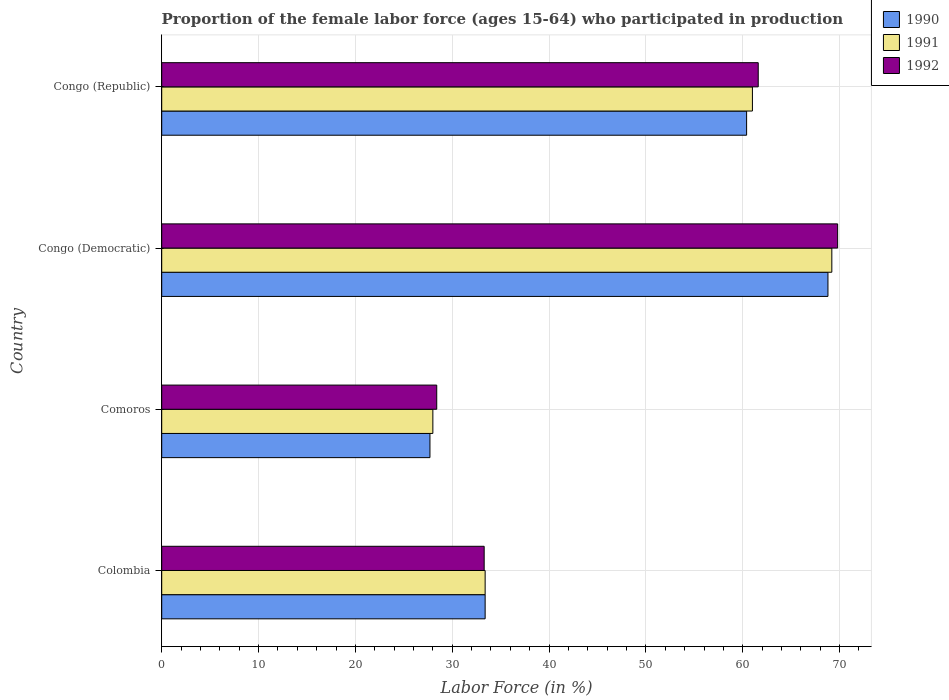How many groups of bars are there?
Your answer should be very brief. 4. Are the number of bars on each tick of the Y-axis equal?
Keep it short and to the point. Yes. How many bars are there on the 3rd tick from the top?
Provide a succinct answer. 3. What is the label of the 3rd group of bars from the top?
Keep it short and to the point. Comoros. In how many cases, is the number of bars for a given country not equal to the number of legend labels?
Your answer should be very brief. 0. What is the proportion of the female labor force who participated in production in 1991 in Congo (Republic)?
Provide a succinct answer. 61. Across all countries, what is the maximum proportion of the female labor force who participated in production in 1992?
Offer a very short reply. 69.8. Across all countries, what is the minimum proportion of the female labor force who participated in production in 1990?
Make the answer very short. 27.7. In which country was the proportion of the female labor force who participated in production in 1991 maximum?
Offer a very short reply. Congo (Democratic). In which country was the proportion of the female labor force who participated in production in 1990 minimum?
Make the answer very short. Comoros. What is the total proportion of the female labor force who participated in production in 1991 in the graph?
Offer a terse response. 191.6. What is the difference between the proportion of the female labor force who participated in production in 1992 in Congo (Democratic) and that in Congo (Republic)?
Provide a short and direct response. 8.2. What is the difference between the proportion of the female labor force who participated in production in 1992 in Comoros and the proportion of the female labor force who participated in production in 1990 in Congo (Republic)?
Offer a terse response. -32. What is the average proportion of the female labor force who participated in production in 1990 per country?
Keep it short and to the point. 47.58. What is the difference between the proportion of the female labor force who participated in production in 1990 and proportion of the female labor force who participated in production in 1992 in Comoros?
Your response must be concise. -0.7. In how many countries, is the proportion of the female labor force who participated in production in 1992 greater than 24 %?
Offer a very short reply. 4. What is the ratio of the proportion of the female labor force who participated in production in 1992 in Comoros to that in Congo (Democratic)?
Make the answer very short. 0.41. Is the difference between the proportion of the female labor force who participated in production in 1990 in Comoros and Congo (Democratic) greater than the difference between the proportion of the female labor force who participated in production in 1992 in Comoros and Congo (Democratic)?
Offer a very short reply. Yes. What is the difference between the highest and the second highest proportion of the female labor force who participated in production in 1992?
Give a very brief answer. 8.2. What is the difference between the highest and the lowest proportion of the female labor force who participated in production in 1990?
Provide a short and direct response. 41.1. In how many countries, is the proportion of the female labor force who participated in production in 1991 greater than the average proportion of the female labor force who participated in production in 1991 taken over all countries?
Your answer should be compact. 2. Is it the case that in every country, the sum of the proportion of the female labor force who participated in production in 1990 and proportion of the female labor force who participated in production in 1991 is greater than the proportion of the female labor force who participated in production in 1992?
Make the answer very short. Yes. How many bars are there?
Your answer should be compact. 12. How many countries are there in the graph?
Your answer should be compact. 4. Does the graph contain grids?
Offer a very short reply. Yes. Where does the legend appear in the graph?
Your answer should be very brief. Top right. What is the title of the graph?
Keep it short and to the point. Proportion of the female labor force (ages 15-64) who participated in production. Does "2006" appear as one of the legend labels in the graph?
Make the answer very short. No. What is the Labor Force (in %) in 1990 in Colombia?
Provide a succinct answer. 33.4. What is the Labor Force (in %) of 1991 in Colombia?
Your response must be concise. 33.4. What is the Labor Force (in %) in 1992 in Colombia?
Ensure brevity in your answer.  33.3. What is the Labor Force (in %) in 1990 in Comoros?
Offer a terse response. 27.7. What is the Labor Force (in %) of 1992 in Comoros?
Keep it short and to the point. 28.4. What is the Labor Force (in %) of 1990 in Congo (Democratic)?
Your answer should be compact. 68.8. What is the Labor Force (in %) in 1991 in Congo (Democratic)?
Keep it short and to the point. 69.2. What is the Labor Force (in %) of 1992 in Congo (Democratic)?
Give a very brief answer. 69.8. What is the Labor Force (in %) of 1990 in Congo (Republic)?
Offer a very short reply. 60.4. What is the Labor Force (in %) of 1992 in Congo (Republic)?
Provide a short and direct response. 61.6. Across all countries, what is the maximum Labor Force (in %) in 1990?
Provide a succinct answer. 68.8. Across all countries, what is the maximum Labor Force (in %) of 1991?
Ensure brevity in your answer.  69.2. Across all countries, what is the maximum Labor Force (in %) in 1992?
Provide a succinct answer. 69.8. Across all countries, what is the minimum Labor Force (in %) of 1990?
Provide a succinct answer. 27.7. Across all countries, what is the minimum Labor Force (in %) of 1991?
Provide a short and direct response. 28. Across all countries, what is the minimum Labor Force (in %) in 1992?
Provide a short and direct response. 28.4. What is the total Labor Force (in %) in 1990 in the graph?
Provide a succinct answer. 190.3. What is the total Labor Force (in %) of 1991 in the graph?
Your answer should be very brief. 191.6. What is the total Labor Force (in %) of 1992 in the graph?
Offer a very short reply. 193.1. What is the difference between the Labor Force (in %) of 1990 in Colombia and that in Comoros?
Give a very brief answer. 5.7. What is the difference between the Labor Force (in %) of 1992 in Colombia and that in Comoros?
Make the answer very short. 4.9. What is the difference between the Labor Force (in %) of 1990 in Colombia and that in Congo (Democratic)?
Make the answer very short. -35.4. What is the difference between the Labor Force (in %) of 1991 in Colombia and that in Congo (Democratic)?
Provide a short and direct response. -35.8. What is the difference between the Labor Force (in %) of 1992 in Colombia and that in Congo (Democratic)?
Your answer should be compact. -36.5. What is the difference between the Labor Force (in %) in 1990 in Colombia and that in Congo (Republic)?
Provide a succinct answer. -27. What is the difference between the Labor Force (in %) in 1991 in Colombia and that in Congo (Republic)?
Your response must be concise. -27.6. What is the difference between the Labor Force (in %) in 1992 in Colombia and that in Congo (Republic)?
Offer a terse response. -28.3. What is the difference between the Labor Force (in %) of 1990 in Comoros and that in Congo (Democratic)?
Provide a short and direct response. -41.1. What is the difference between the Labor Force (in %) of 1991 in Comoros and that in Congo (Democratic)?
Your response must be concise. -41.2. What is the difference between the Labor Force (in %) in 1992 in Comoros and that in Congo (Democratic)?
Your response must be concise. -41.4. What is the difference between the Labor Force (in %) of 1990 in Comoros and that in Congo (Republic)?
Offer a very short reply. -32.7. What is the difference between the Labor Force (in %) of 1991 in Comoros and that in Congo (Republic)?
Your answer should be compact. -33. What is the difference between the Labor Force (in %) in 1992 in Comoros and that in Congo (Republic)?
Your answer should be very brief. -33.2. What is the difference between the Labor Force (in %) in 1992 in Congo (Democratic) and that in Congo (Republic)?
Your answer should be compact. 8.2. What is the difference between the Labor Force (in %) of 1990 in Colombia and the Labor Force (in %) of 1991 in Congo (Democratic)?
Ensure brevity in your answer.  -35.8. What is the difference between the Labor Force (in %) of 1990 in Colombia and the Labor Force (in %) of 1992 in Congo (Democratic)?
Make the answer very short. -36.4. What is the difference between the Labor Force (in %) of 1991 in Colombia and the Labor Force (in %) of 1992 in Congo (Democratic)?
Your answer should be very brief. -36.4. What is the difference between the Labor Force (in %) in 1990 in Colombia and the Labor Force (in %) in 1991 in Congo (Republic)?
Keep it short and to the point. -27.6. What is the difference between the Labor Force (in %) in 1990 in Colombia and the Labor Force (in %) in 1992 in Congo (Republic)?
Keep it short and to the point. -28.2. What is the difference between the Labor Force (in %) in 1991 in Colombia and the Labor Force (in %) in 1992 in Congo (Republic)?
Provide a short and direct response. -28.2. What is the difference between the Labor Force (in %) in 1990 in Comoros and the Labor Force (in %) in 1991 in Congo (Democratic)?
Your answer should be very brief. -41.5. What is the difference between the Labor Force (in %) of 1990 in Comoros and the Labor Force (in %) of 1992 in Congo (Democratic)?
Your response must be concise. -42.1. What is the difference between the Labor Force (in %) in 1991 in Comoros and the Labor Force (in %) in 1992 in Congo (Democratic)?
Ensure brevity in your answer.  -41.8. What is the difference between the Labor Force (in %) of 1990 in Comoros and the Labor Force (in %) of 1991 in Congo (Republic)?
Your response must be concise. -33.3. What is the difference between the Labor Force (in %) of 1990 in Comoros and the Labor Force (in %) of 1992 in Congo (Republic)?
Ensure brevity in your answer.  -33.9. What is the difference between the Labor Force (in %) of 1991 in Comoros and the Labor Force (in %) of 1992 in Congo (Republic)?
Offer a terse response. -33.6. What is the difference between the Labor Force (in %) in 1990 in Congo (Democratic) and the Labor Force (in %) in 1991 in Congo (Republic)?
Give a very brief answer. 7.8. What is the difference between the Labor Force (in %) of 1991 in Congo (Democratic) and the Labor Force (in %) of 1992 in Congo (Republic)?
Make the answer very short. 7.6. What is the average Labor Force (in %) of 1990 per country?
Ensure brevity in your answer.  47.58. What is the average Labor Force (in %) of 1991 per country?
Your response must be concise. 47.9. What is the average Labor Force (in %) in 1992 per country?
Give a very brief answer. 48.27. What is the difference between the Labor Force (in %) of 1991 and Labor Force (in %) of 1992 in Colombia?
Provide a succinct answer. 0.1. What is the difference between the Labor Force (in %) in 1990 and Labor Force (in %) in 1991 in Comoros?
Your answer should be compact. -0.3. What is the difference between the Labor Force (in %) in 1990 and Labor Force (in %) in 1992 in Comoros?
Give a very brief answer. -0.7. What is the difference between the Labor Force (in %) in 1990 and Labor Force (in %) in 1991 in Congo (Republic)?
Give a very brief answer. -0.6. What is the difference between the Labor Force (in %) of 1991 and Labor Force (in %) of 1992 in Congo (Republic)?
Provide a short and direct response. -0.6. What is the ratio of the Labor Force (in %) in 1990 in Colombia to that in Comoros?
Offer a terse response. 1.21. What is the ratio of the Labor Force (in %) in 1991 in Colombia to that in Comoros?
Provide a short and direct response. 1.19. What is the ratio of the Labor Force (in %) in 1992 in Colombia to that in Comoros?
Make the answer very short. 1.17. What is the ratio of the Labor Force (in %) in 1990 in Colombia to that in Congo (Democratic)?
Make the answer very short. 0.49. What is the ratio of the Labor Force (in %) of 1991 in Colombia to that in Congo (Democratic)?
Keep it short and to the point. 0.48. What is the ratio of the Labor Force (in %) in 1992 in Colombia to that in Congo (Democratic)?
Your answer should be compact. 0.48. What is the ratio of the Labor Force (in %) of 1990 in Colombia to that in Congo (Republic)?
Your answer should be very brief. 0.55. What is the ratio of the Labor Force (in %) in 1991 in Colombia to that in Congo (Republic)?
Ensure brevity in your answer.  0.55. What is the ratio of the Labor Force (in %) in 1992 in Colombia to that in Congo (Republic)?
Offer a terse response. 0.54. What is the ratio of the Labor Force (in %) in 1990 in Comoros to that in Congo (Democratic)?
Your answer should be very brief. 0.4. What is the ratio of the Labor Force (in %) of 1991 in Comoros to that in Congo (Democratic)?
Make the answer very short. 0.4. What is the ratio of the Labor Force (in %) in 1992 in Comoros to that in Congo (Democratic)?
Your response must be concise. 0.41. What is the ratio of the Labor Force (in %) of 1990 in Comoros to that in Congo (Republic)?
Offer a very short reply. 0.46. What is the ratio of the Labor Force (in %) in 1991 in Comoros to that in Congo (Republic)?
Ensure brevity in your answer.  0.46. What is the ratio of the Labor Force (in %) in 1992 in Comoros to that in Congo (Republic)?
Ensure brevity in your answer.  0.46. What is the ratio of the Labor Force (in %) in 1990 in Congo (Democratic) to that in Congo (Republic)?
Offer a terse response. 1.14. What is the ratio of the Labor Force (in %) in 1991 in Congo (Democratic) to that in Congo (Republic)?
Give a very brief answer. 1.13. What is the ratio of the Labor Force (in %) in 1992 in Congo (Democratic) to that in Congo (Republic)?
Keep it short and to the point. 1.13. What is the difference between the highest and the second highest Labor Force (in %) of 1990?
Give a very brief answer. 8.4. What is the difference between the highest and the second highest Labor Force (in %) in 1992?
Give a very brief answer. 8.2. What is the difference between the highest and the lowest Labor Force (in %) in 1990?
Ensure brevity in your answer.  41.1. What is the difference between the highest and the lowest Labor Force (in %) in 1991?
Offer a very short reply. 41.2. What is the difference between the highest and the lowest Labor Force (in %) of 1992?
Make the answer very short. 41.4. 